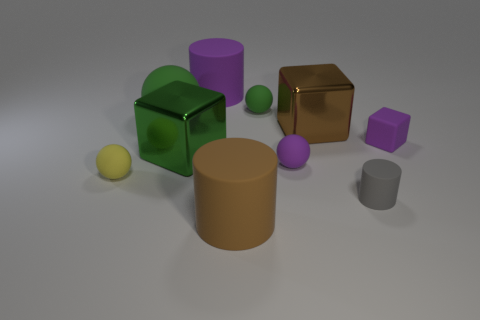Subtract all gray matte cylinders. How many cylinders are left? 2 Subtract all purple balls. How many balls are left? 3 Subtract all cylinders. How many objects are left? 7 Subtract 2 blocks. How many blocks are left? 1 Add 7 tiny brown rubber cubes. How many tiny brown rubber cubes exist? 7 Subtract 0 brown balls. How many objects are left? 10 Subtract all cyan cylinders. Subtract all red blocks. How many cylinders are left? 3 Subtract all purple cubes. How many brown balls are left? 0 Subtract all large green rubber spheres. Subtract all big matte cylinders. How many objects are left? 7 Add 1 green shiny blocks. How many green shiny blocks are left? 2 